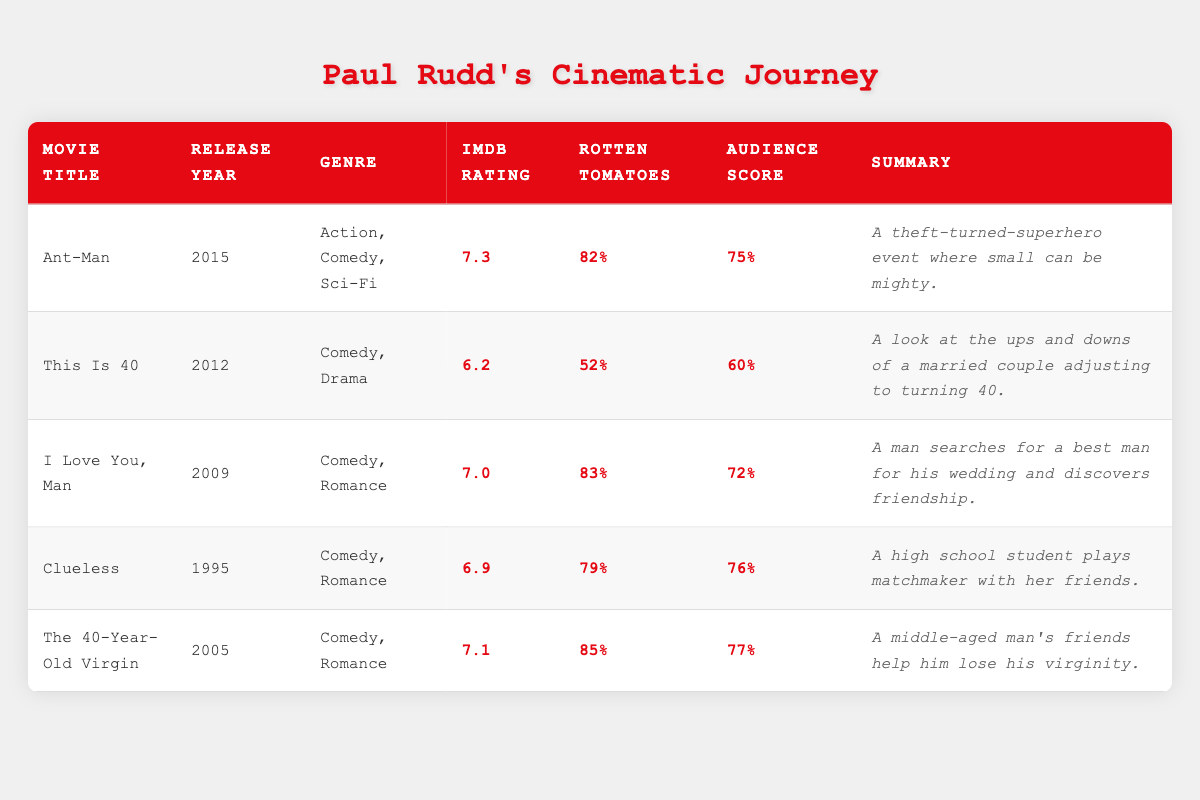What is the highest IMDb rating among Paul Rudd's movies listed? The IMDb ratings in the table are: Ant-Man (7.3), This Is 40 (6.2), I Love You, Man (7.0), Clueless (6.9), and The 40-Year-Old Virgin (7.1). The highest rating is 7.3 for Ant-Man.
Answer: 7.3 Which movie has the lowest Rotten Tomatoes rating? The Rotten Tomatoes ratings are: Ant-Man (82%), This Is 40 (52%), I Love You, Man (83%), Clueless (79%), and The 40-Year-Old Virgin (85%). The lowest rating is 52% for This Is 40.
Answer: 52% Is I Love You, Man rated better than Clueless on Rotten Tomatoes? I Love You, Man has a Rotten Tomatoes rating of 83%, while Clueless has a rating of 79%. Since 83% is greater than 79%, it is true that I Love You, Man is rated better than Clueless.
Answer: Yes What percentage of audience reviews are higher than 70? The movies with audience scores above 70% are: Ant-Man (75%), I Love You, Man (72%), The 40-Year-Old Virgin (77%). There are 5 movies in total, so the percentage is (3/5) * 100 = 60%.
Answer: 60% What is the average IMDb rating of all movies listed? The IMDb ratings are: 7.3, 6.2, 7.0, 6.9, and 7.1. Summing these gives 34.5. Dividing by 5 (the number of movies) gives an average of 34.5 / 5 = 6.9.
Answer: 6.9 Which movie released in 2015 has the highest audience score? The movie released in 2015 is Ant-Man, which has an audience score of 75%. It is the only movie from that year in the table, thus it has the highest score.
Answer: 75% How many user reviews does The 40-Year-Old Virgin have compared to This Is 40? The 40-Year-Old Virgin has 9500 user reviews, while This Is 40 has 2000. The difference is 9500 - 2000 = 7500, meaning it has 7500 more user reviews.
Answer: 7500 more reviews Which Paul Rudd movie has the longest summary? The summaries are: Ant-Man (53 characters), This Is 40 (72 characters), I Love You, Man (73 characters), Clueless (67 characters), and The 40-Year-Old Virgin (67 characters). This Is 40 has the longest summary at 72 characters.
Answer: This Is 40 